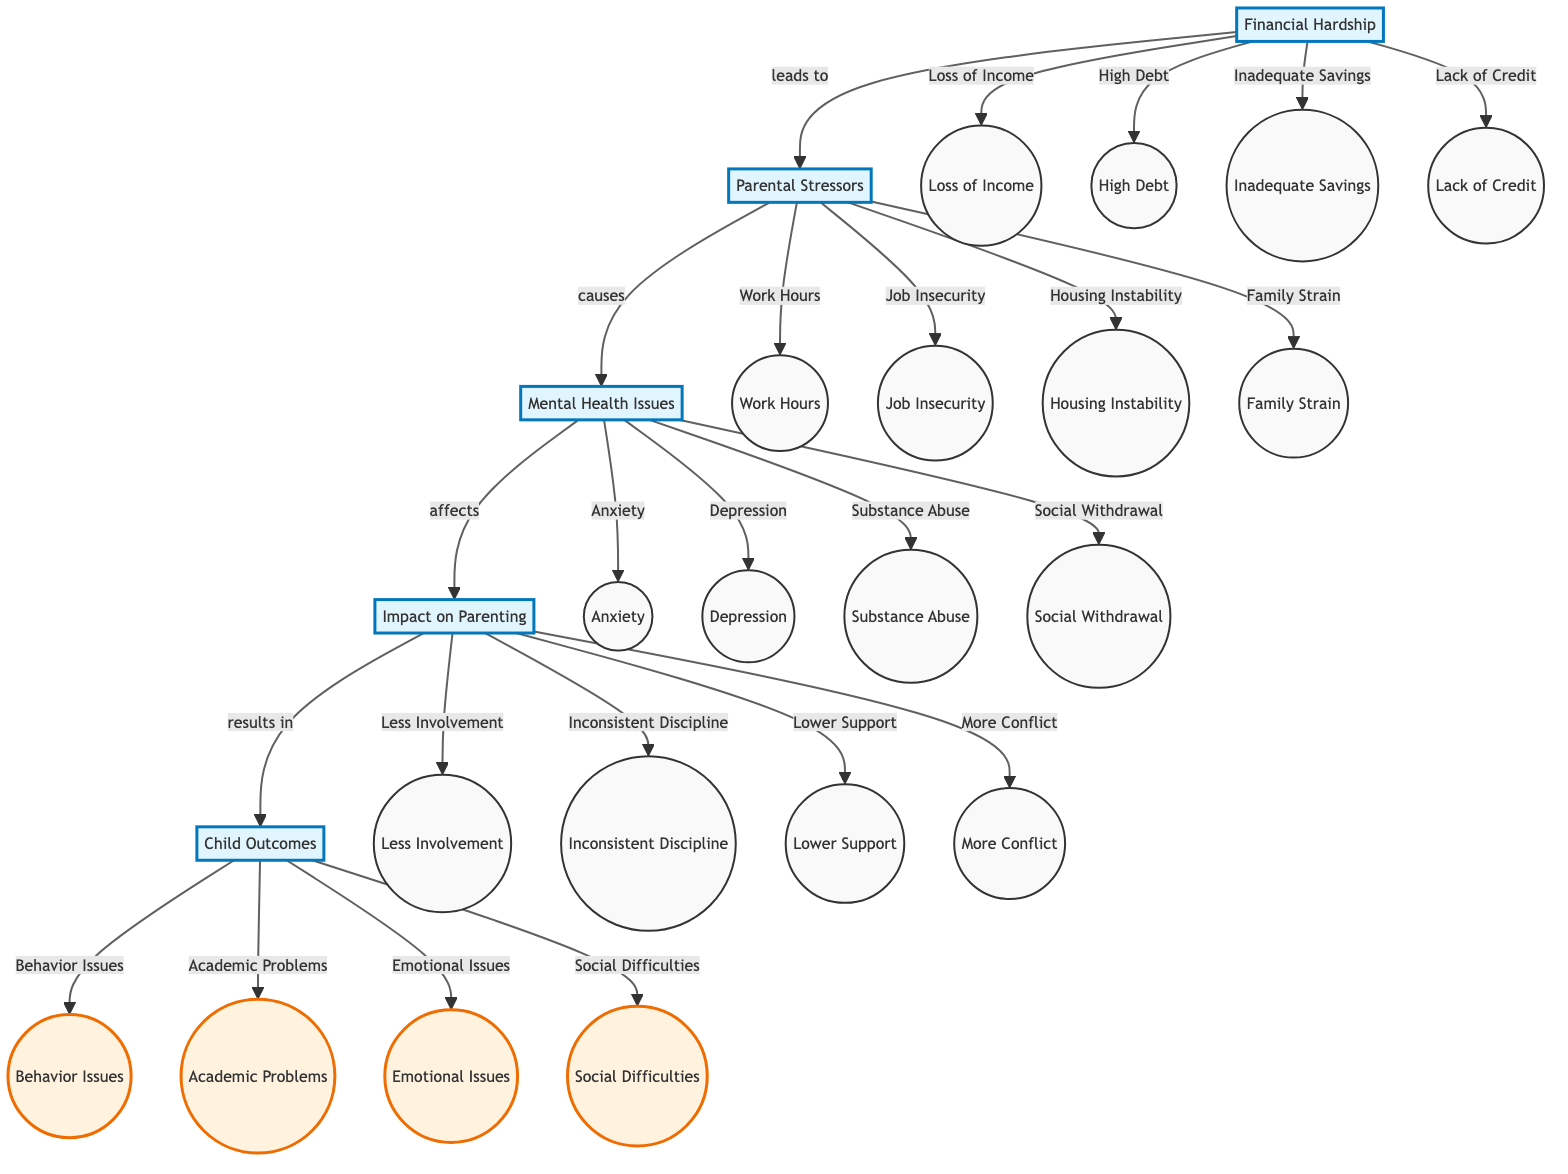What is the first step in the pathway? The diagram begins with "Financial Hardship" as the first step, indicating it as the starting point in the sequence of the clinical pathway.
Answer: Financial Hardship How many main steps are present in the diagram? By counting the main stages presented in the pathway—there are five distinct steps: Financial Hardship, Parental Stressors, Mental Health Issues, Impact on Parenting, and Child Outcomes—this gives a total of five main steps.
Answer: 5 What does "Mental Health Issues" lead to? "Mental Health Issues" in the diagram directly leads to the next step, which is "Impact on Parenting," indicating the sequential relationship between these two concepts.
Answer: Impact on Parenting What specific issue is associated with "Financial Hardship"? Under "Financial Hardship," one of the detailed issues is "Loss of Income," which points to a specific financial difficulty related to this broader category.
Answer: Loss of Income Which step directly connects "Impact on Parenting" and "Child Outcomes"? The connection from "Impact on Parenting" to "Child Outcomes" is indicated as a resulting relationship in the pathway, establishing that parenting impacts subsequently influence child outcomes.
Answer: Child Outcomes What type of mental health issue is directly mentioned after "Parental Stressors"? Following the "Parental Stressors," one of the direct implications is "Mental Health Issues," specifically detailing various problems—including anxiety, which is notably highlighted in the pathway.
Answer: Anxiety How does "Financial Hardship" impact parental stress? The diagram shows that "Financial Hardship" leads to increased "Parental Stressors," suggesting that financial struggles intensify parental stress levels, establishing a direct cause-effect relationship between the two.
Answer: Parental Stressors List one impact of "Mental Health Issues" on parenting. According to the diagram, one notable impact of "Mental Health Issues" on parenting is "Decreased Parental Involvement," indicating how mental health struggles can affect parenting quality.
Answer: Decreased Parental Involvement Which type of problems are related to "Child Outcomes"? The "Child Outcomes" node in the diagram includes several types, such as "Behavioral Problems," showcasing that these outcomes stem from earlier steps in the pathway.
Answer: Behavioral Problems 